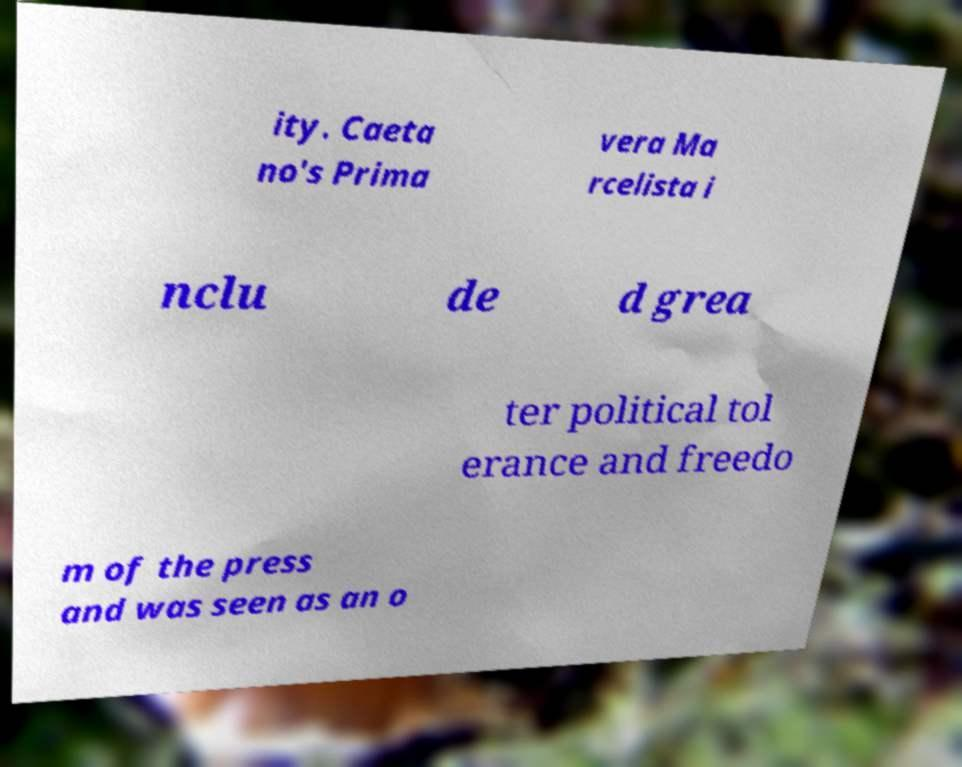Could you extract and type out the text from this image? ity. Caeta no's Prima vera Ma rcelista i nclu de d grea ter political tol erance and freedo m of the press and was seen as an o 